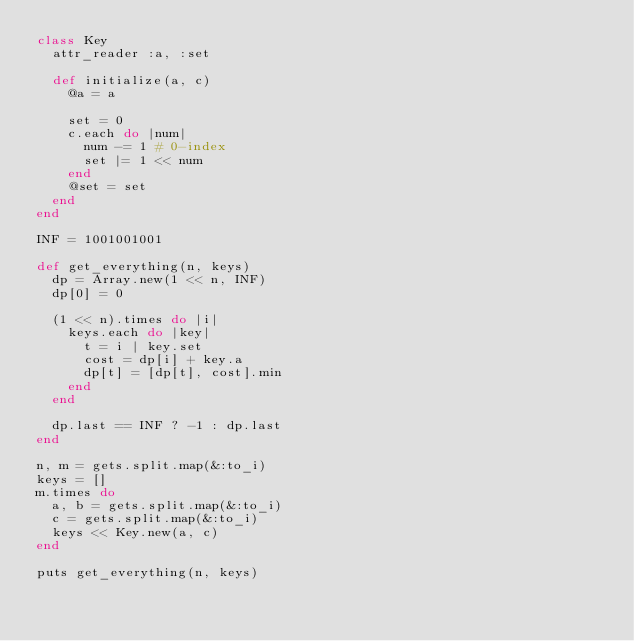<code> <loc_0><loc_0><loc_500><loc_500><_Ruby_>class Key
  attr_reader :a, :set

  def initialize(a, c)
    @a = a

    set = 0
    c.each do |num|
      num -= 1 # 0-index
      set |= 1 << num
    end
    @set = set
  end
end

INF = 1001001001

def get_everything(n, keys)
  dp = Array.new(1 << n, INF)
  dp[0] = 0

  (1 << n).times do |i|
    keys.each do |key|
      t = i | key.set
      cost = dp[i] + key.a
      dp[t] = [dp[t], cost].min
    end
  end
  
  dp.last == INF ? -1 : dp.last
end

n, m = gets.split.map(&:to_i)
keys = []
m.times do
  a, b = gets.split.map(&:to_i)
  c = gets.split.map(&:to_i)
  keys << Key.new(a, c)
end

puts get_everything(n, keys)
</code> 